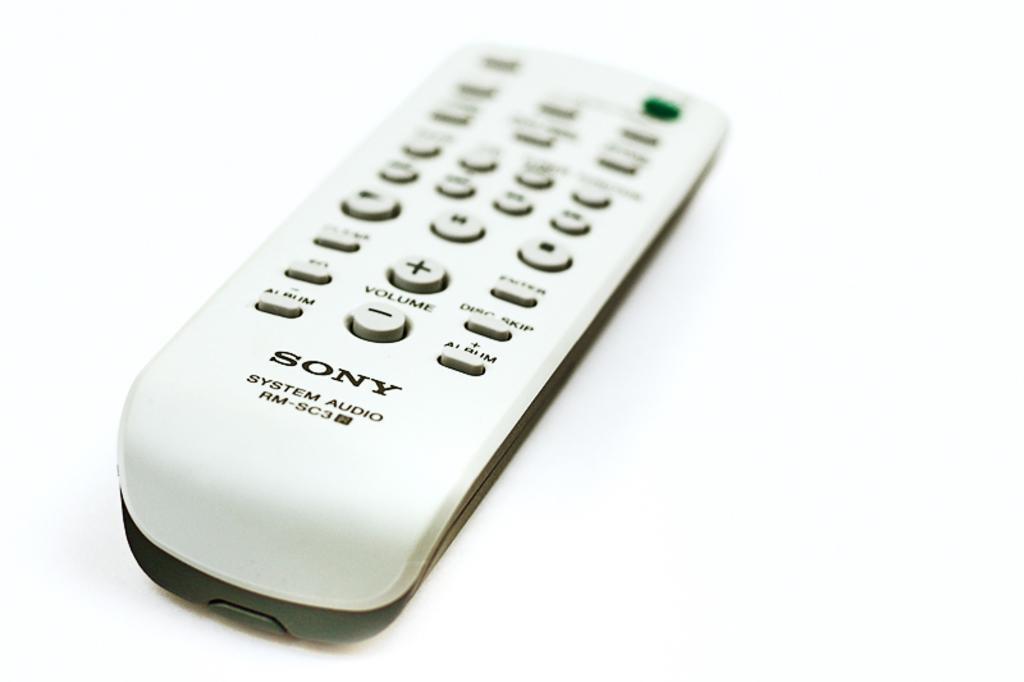<image>
Create a compact narrative representing the image presented. White Sony controller in front of a white background. 